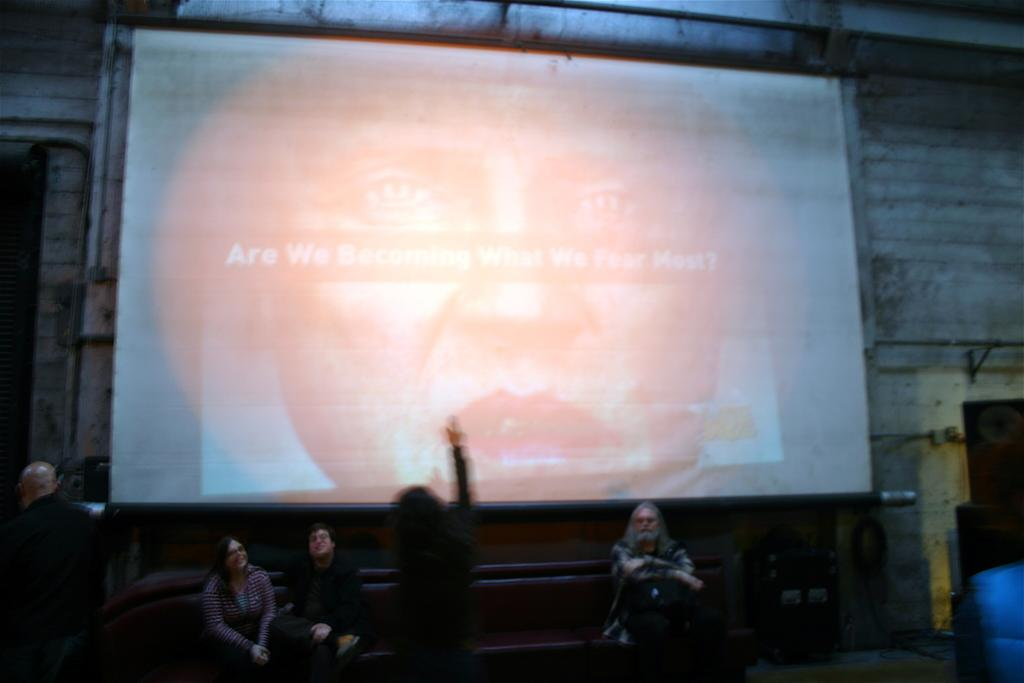What is the main object in the image? There is a screen in the image. What can be seen behind the screen? There is a wall in the image. What are the people in the image doing? People are sitting and standing in the image. What type of bone can be seen in the image? There is no bone present in the image. How do the people in the image react to the birth of a newborn? There is no information about a birth or any reactions in the image. 